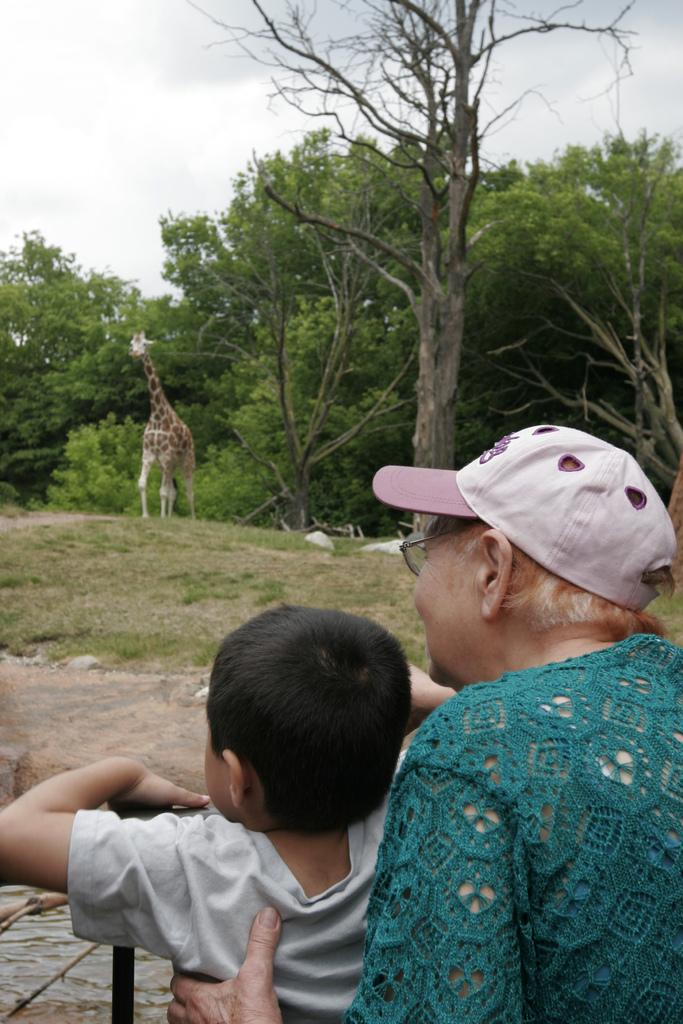How many people are in the image? There are two persons in the image. What other animals or objects can be seen in the image? There is a giraffe in the image. What type of natural vegetation is present in the image? There are trees in the image. What is visible in the sky in the image? Clouds are visible in the sky. What type of honey is being used to paint the giraffe in the image? There is no honey present in the image, nor is the giraffe being painted. 